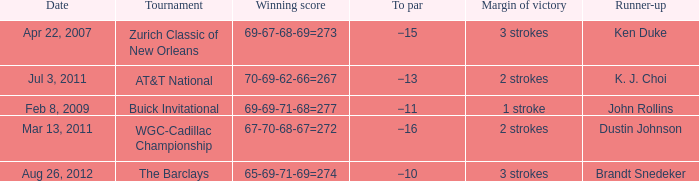What is the date that has a winning score of 67-70-68-67=272? Mar 13, 2011. 